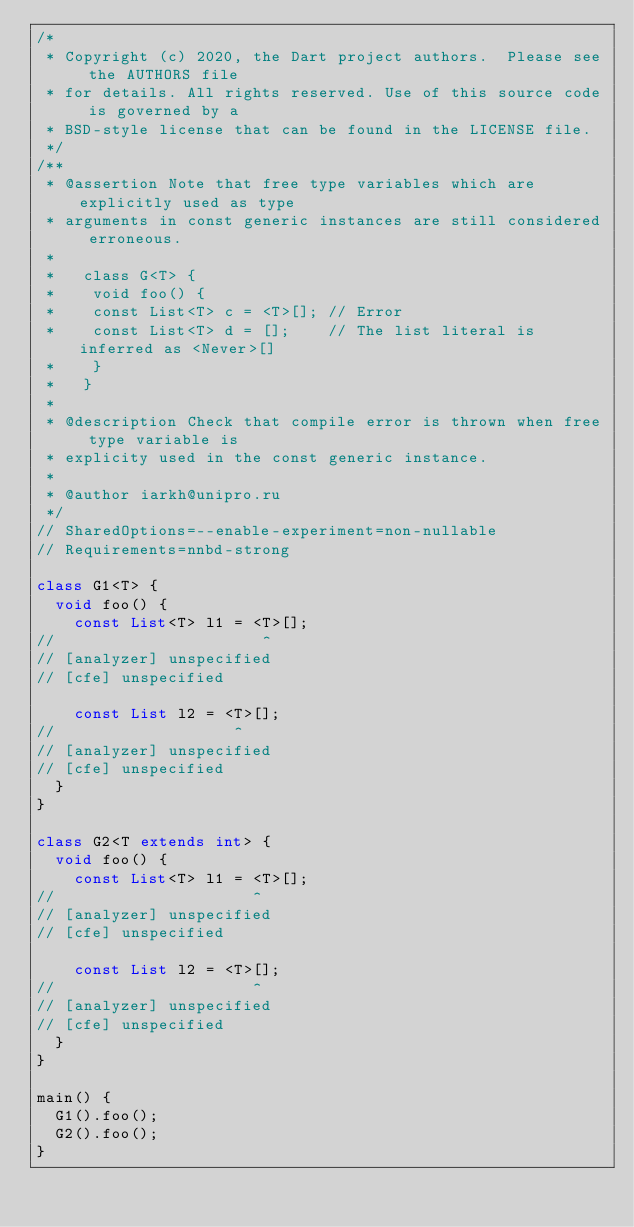Convert code to text. <code><loc_0><loc_0><loc_500><loc_500><_Dart_>/*
 * Copyright (c) 2020, the Dart project authors.  Please see the AUTHORS file
 * for details. All rights reserved. Use of this source code is governed by a
 * BSD-style license that can be found in the LICENSE file.
 */
/**
 * @assertion Note that free type variables which are explicitly used as type
 * arguments in const generic instances are still considered erroneous.
 *
 *   class G<T> {
 *    void foo() {
 *    const List<T> c = <T>[]; // Error
 *    const List<T> d = [];    // The list literal is inferred as <Never>[]
 *    }
 *   }
 *
 * @description Check that compile error is thrown when free type variable is
 * explicity used in the const generic instance.
 *
 * @author iarkh@unipro.ru
 */
// SharedOptions=--enable-experiment=non-nullable
// Requirements=nnbd-strong

class G1<T> {
  void foo() {
    const List<T> l1 = <T>[];
//                      ^
// [analyzer] unspecified
// [cfe] unspecified

    const List l2 = <T>[];
//                   ^
// [analyzer] unspecified
// [cfe] unspecified
  }
}

class G2<T extends int> {
  void foo() {
    const List<T> l1 = <T>[];
//                     ^
// [analyzer] unspecified
// [cfe] unspecified

    const List l2 = <T>[];
//                     ^
// [analyzer] unspecified
// [cfe] unspecified
  }
}

main() {
  G1().foo();
  G2().foo();
}
</code> 